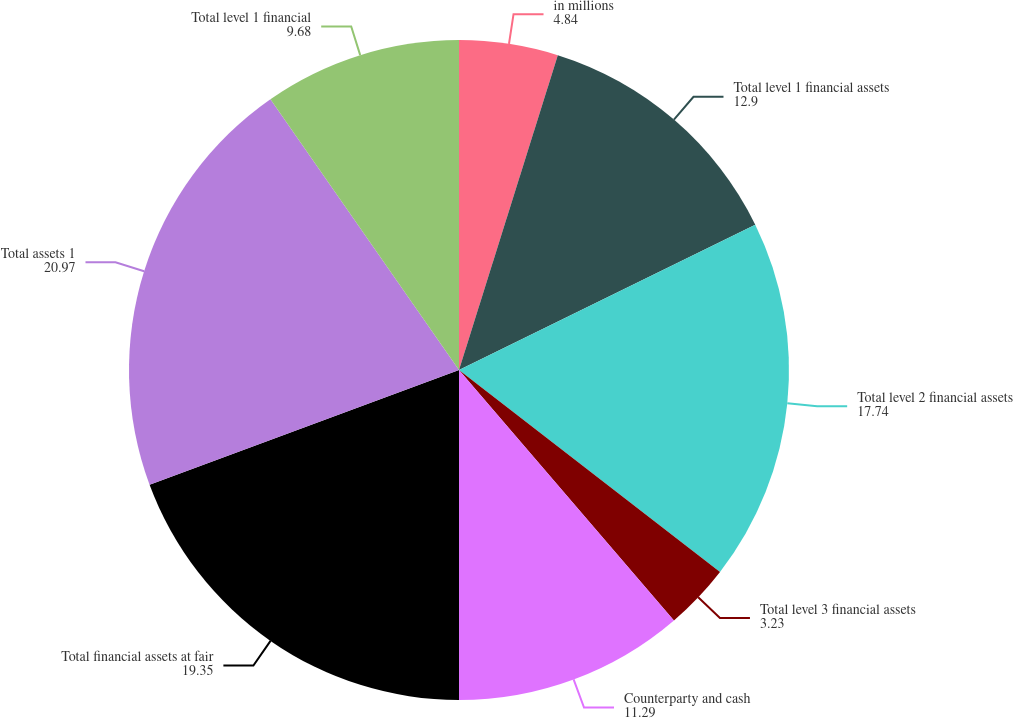Convert chart to OTSL. <chart><loc_0><loc_0><loc_500><loc_500><pie_chart><fcel>in millions<fcel>Total level 1 financial assets<fcel>Total level 2 financial assets<fcel>Total level 3 financial assets<fcel>Counterparty and cash<fcel>Total financial assets at fair<fcel>Total assets 1<fcel>Total level 1 financial<nl><fcel>4.84%<fcel>12.9%<fcel>17.74%<fcel>3.23%<fcel>11.29%<fcel>19.35%<fcel>20.97%<fcel>9.68%<nl></chart> 